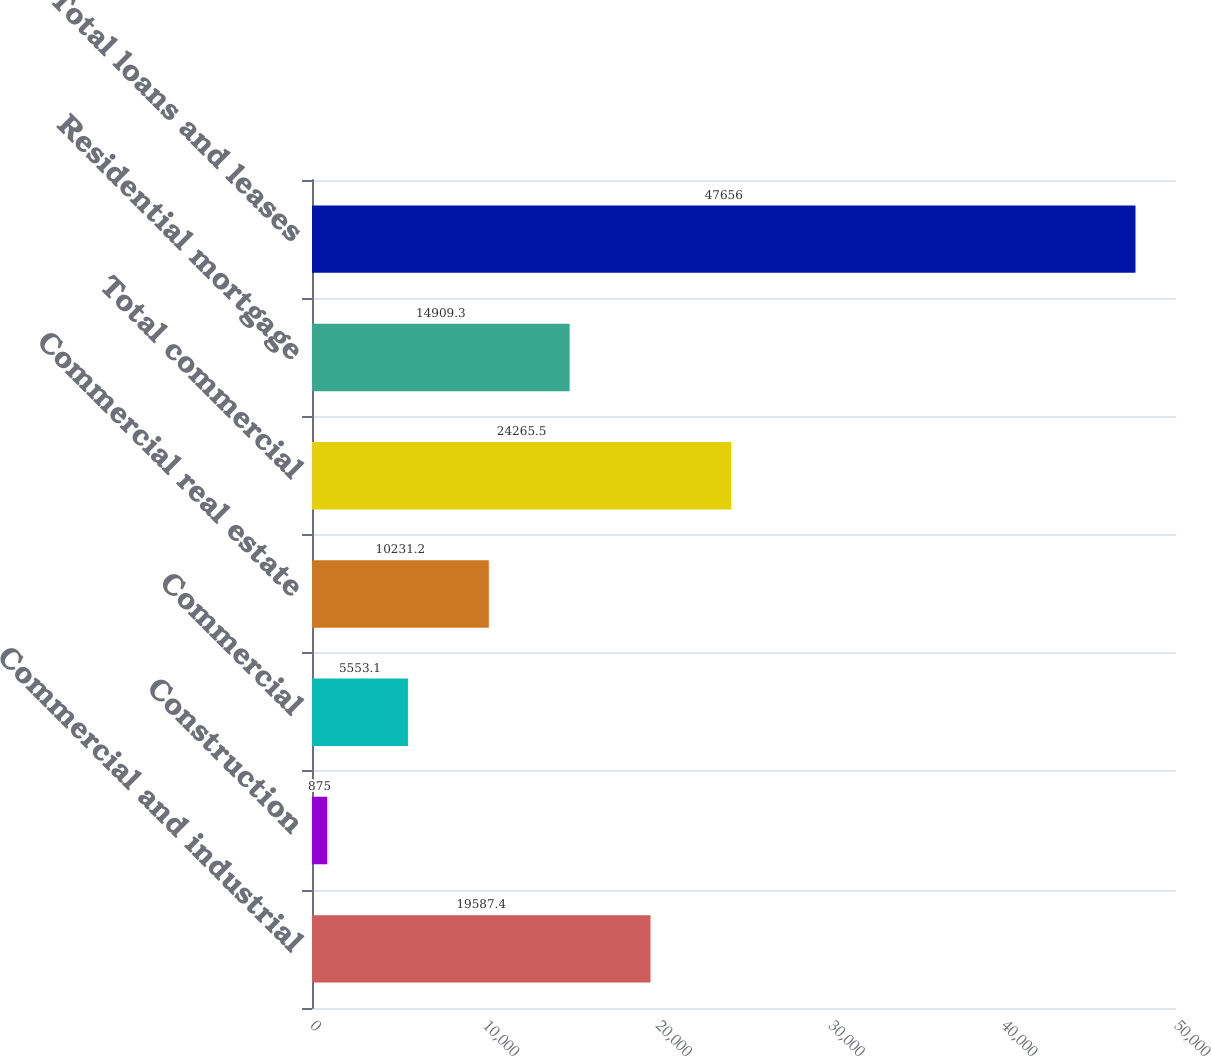<chart> <loc_0><loc_0><loc_500><loc_500><bar_chart><fcel>Commercial and industrial<fcel>Construction<fcel>Commercial<fcel>Commercial real estate<fcel>Total commercial<fcel>Residential mortgage<fcel>Total loans and leases<nl><fcel>19587.4<fcel>875<fcel>5553.1<fcel>10231.2<fcel>24265.5<fcel>14909.3<fcel>47656<nl></chart> 